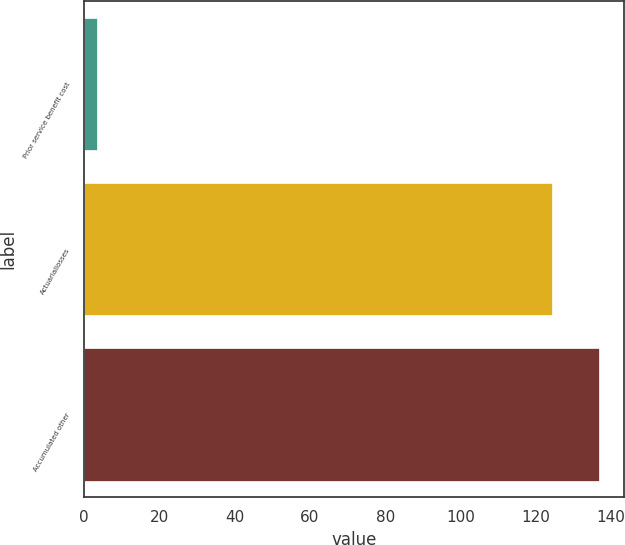<chart> <loc_0><loc_0><loc_500><loc_500><bar_chart><fcel>Prior service benefit cost<fcel>Actuariallosses<fcel>Accumulated other<nl><fcel>3.5<fcel>124.3<fcel>136.73<nl></chart> 